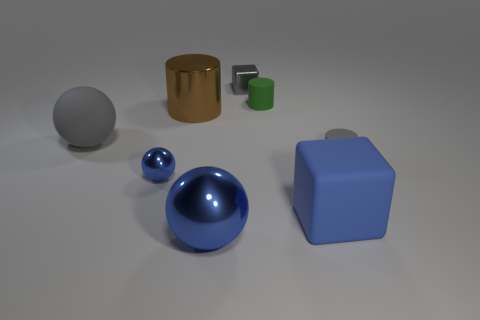Can you describe the shapes and materials of the objects in the image? Certainly, the image displays a collection of six objects, each with a distinct shape and presumed material. Starting from the left, there's a matte spherical object likely made of a rubber-like material, a metallic shiny cylinder, a small reflective sphere possibly made of metal, a smaller green cube that might be rubber, a larger blue cube with a matte finish suggesting a plastic composition, and finally, a shiny smaller cylinder with a metallic sheen, possibly steel. 